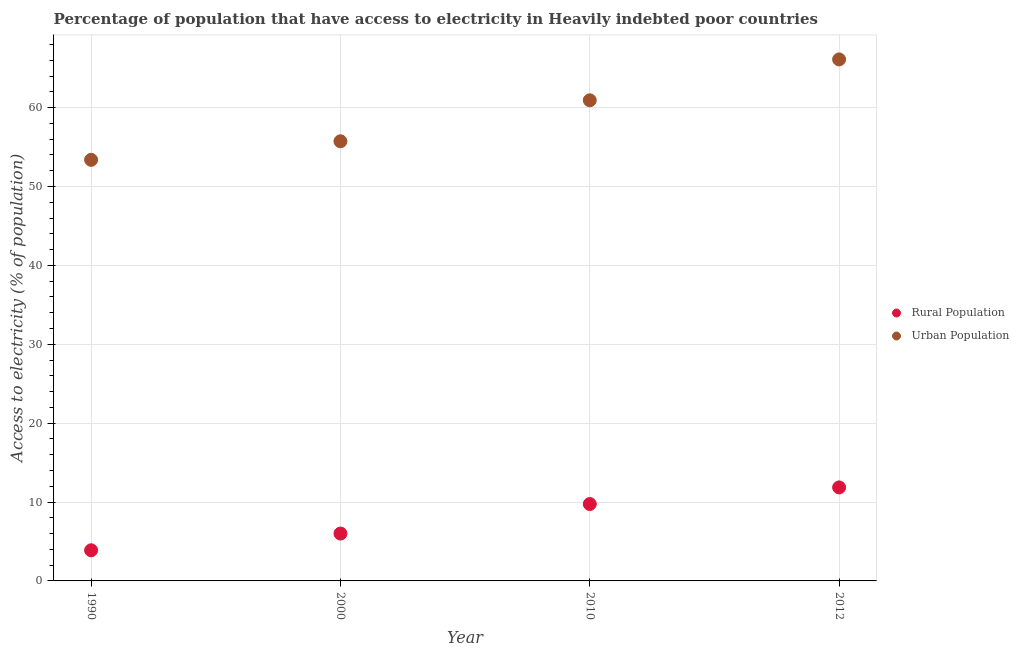Is the number of dotlines equal to the number of legend labels?
Offer a terse response. Yes. What is the percentage of urban population having access to electricity in 2000?
Provide a succinct answer. 55.73. Across all years, what is the maximum percentage of rural population having access to electricity?
Your response must be concise. 11.85. Across all years, what is the minimum percentage of rural population having access to electricity?
Provide a succinct answer. 3.88. In which year was the percentage of urban population having access to electricity minimum?
Give a very brief answer. 1990. What is the total percentage of rural population having access to electricity in the graph?
Make the answer very short. 31.49. What is the difference between the percentage of urban population having access to electricity in 1990 and that in 2000?
Offer a terse response. -2.35. What is the difference between the percentage of urban population having access to electricity in 2010 and the percentage of rural population having access to electricity in 1990?
Provide a succinct answer. 57.04. What is the average percentage of rural population having access to electricity per year?
Provide a short and direct response. 7.87. In the year 1990, what is the difference between the percentage of rural population having access to electricity and percentage of urban population having access to electricity?
Keep it short and to the point. -49.49. In how many years, is the percentage of urban population having access to electricity greater than 44 %?
Your response must be concise. 4. What is the ratio of the percentage of urban population having access to electricity in 2010 to that in 2012?
Your answer should be very brief. 0.92. Is the percentage of rural population having access to electricity in 1990 less than that in 2012?
Keep it short and to the point. Yes. Is the difference between the percentage of rural population having access to electricity in 2000 and 2012 greater than the difference between the percentage of urban population having access to electricity in 2000 and 2012?
Provide a short and direct response. Yes. What is the difference between the highest and the second highest percentage of urban population having access to electricity?
Your answer should be compact. 5.18. What is the difference between the highest and the lowest percentage of urban population having access to electricity?
Offer a very short reply. 12.73. Is the sum of the percentage of rural population having access to electricity in 1990 and 2000 greater than the maximum percentage of urban population having access to electricity across all years?
Your answer should be compact. No. Does the percentage of rural population having access to electricity monotonically increase over the years?
Provide a succinct answer. Yes. How many years are there in the graph?
Your response must be concise. 4. Does the graph contain any zero values?
Give a very brief answer. No. Does the graph contain grids?
Your response must be concise. Yes. How many legend labels are there?
Your response must be concise. 2. How are the legend labels stacked?
Provide a short and direct response. Vertical. What is the title of the graph?
Your response must be concise. Percentage of population that have access to electricity in Heavily indebted poor countries. What is the label or title of the X-axis?
Offer a very short reply. Year. What is the label or title of the Y-axis?
Provide a short and direct response. Access to electricity (% of population). What is the Access to electricity (% of population) of Rural Population in 1990?
Make the answer very short. 3.88. What is the Access to electricity (% of population) of Urban Population in 1990?
Your answer should be compact. 53.37. What is the Access to electricity (% of population) in Rural Population in 2000?
Provide a succinct answer. 6. What is the Access to electricity (% of population) of Urban Population in 2000?
Your response must be concise. 55.73. What is the Access to electricity (% of population) in Rural Population in 2010?
Provide a short and direct response. 9.75. What is the Access to electricity (% of population) of Urban Population in 2010?
Give a very brief answer. 60.92. What is the Access to electricity (% of population) in Rural Population in 2012?
Offer a very short reply. 11.85. What is the Access to electricity (% of population) of Urban Population in 2012?
Make the answer very short. 66.1. Across all years, what is the maximum Access to electricity (% of population) of Rural Population?
Your answer should be compact. 11.85. Across all years, what is the maximum Access to electricity (% of population) in Urban Population?
Your answer should be very brief. 66.1. Across all years, what is the minimum Access to electricity (% of population) in Rural Population?
Keep it short and to the point. 3.88. Across all years, what is the minimum Access to electricity (% of population) of Urban Population?
Give a very brief answer. 53.37. What is the total Access to electricity (% of population) of Rural Population in the graph?
Your response must be concise. 31.49. What is the total Access to electricity (% of population) in Urban Population in the graph?
Make the answer very short. 236.12. What is the difference between the Access to electricity (% of population) in Rural Population in 1990 and that in 2000?
Offer a terse response. -2.12. What is the difference between the Access to electricity (% of population) of Urban Population in 1990 and that in 2000?
Your response must be concise. -2.35. What is the difference between the Access to electricity (% of population) of Rural Population in 1990 and that in 2010?
Your response must be concise. -5.86. What is the difference between the Access to electricity (% of population) in Urban Population in 1990 and that in 2010?
Offer a terse response. -7.55. What is the difference between the Access to electricity (% of population) in Rural Population in 1990 and that in 2012?
Offer a terse response. -7.97. What is the difference between the Access to electricity (% of population) of Urban Population in 1990 and that in 2012?
Provide a short and direct response. -12.73. What is the difference between the Access to electricity (% of population) in Rural Population in 2000 and that in 2010?
Offer a very short reply. -3.74. What is the difference between the Access to electricity (% of population) of Urban Population in 2000 and that in 2010?
Make the answer very short. -5.19. What is the difference between the Access to electricity (% of population) in Rural Population in 2000 and that in 2012?
Your response must be concise. -5.85. What is the difference between the Access to electricity (% of population) in Urban Population in 2000 and that in 2012?
Your response must be concise. -10.37. What is the difference between the Access to electricity (% of population) of Rural Population in 2010 and that in 2012?
Offer a very short reply. -2.11. What is the difference between the Access to electricity (% of population) of Urban Population in 2010 and that in 2012?
Make the answer very short. -5.18. What is the difference between the Access to electricity (% of population) in Rural Population in 1990 and the Access to electricity (% of population) in Urban Population in 2000?
Keep it short and to the point. -51.84. What is the difference between the Access to electricity (% of population) of Rural Population in 1990 and the Access to electricity (% of population) of Urban Population in 2010?
Give a very brief answer. -57.04. What is the difference between the Access to electricity (% of population) of Rural Population in 1990 and the Access to electricity (% of population) of Urban Population in 2012?
Your answer should be very brief. -62.22. What is the difference between the Access to electricity (% of population) in Rural Population in 2000 and the Access to electricity (% of population) in Urban Population in 2010?
Your response must be concise. -54.92. What is the difference between the Access to electricity (% of population) of Rural Population in 2000 and the Access to electricity (% of population) of Urban Population in 2012?
Offer a terse response. -60.1. What is the difference between the Access to electricity (% of population) of Rural Population in 2010 and the Access to electricity (% of population) of Urban Population in 2012?
Provide a short and direct response. -56.36. What is the average Access to electricity (% of population) in Rural Population per year?
Your answer should be compact. 7.87. What is the average Access to electricity (% of population) of Urban Population per year?
Provide a short and direct response. 59.03. In the year 1990, what is the difference between the Access to electricity (% of population) of Rural Population and Access to electricity (% of population) of Urban Population?
Your response must be concise. -49.49. In the year 2000, what is the difference between the Access to electricity (% of population) of Rural Population and Access to electricity (% of population) of Urban Population?
Offer a very short reply. -49.72. In the year 2010, what is the difference between the Access to electricity (% of population) of Rural Population and Access to electricity (% of population) of Urban Population?
Your answer should be very brief. -51.18. In the year 2012, what is the difference between the Access to electricity (% of population) of Rural Population and Access to electricity (% of population) of Urban Population?
Make the answer very short. -54.25. What is the ratio of the Access to electricity (% of population) in Rural Population in 1990 to that in 2000?
Keep it short and to the point. 0.65. What is the ratio of the Access to electricity (% of population) of Urban Population in 1990 to that in 2000?
Your answer should be very brief. 0.96. What is the ratio of the Access to electricity (% of population) of Rural Population in 1990 to that in 2010?
Provide a short and direct response. 0.4. What is the ratio of the Access to electricity (% of population) in Urban Population in 1990 to that in 2010?
Offer a very short reply. 0.88. What is the ratio of the Access to electricity (% of population) in Rural Population in 1990 to that in 2012?
Give a very brief answer. 0.33. What is the ratio of the Access to electricity (% of population) of Urban Population in 1990 to that in 2012?
Keep it short and to the point. 0.81. What is the ratio of the Access to electricity (% of population) of Rural Population in 2000 to that in 2010?
Offer a very short reply. 0.62. What is the ratio of the Access to electricity (% of population) of Urban Population in 2000 to that in 2010?
Offer a terse response. 0.91. What is the ratio of the Access to electricity (% of population) in Rural Population in 2000 to that in 2012?
Offer a terse response. 0.51. What is the ratio of the Access to electricity (% of population) of Urban Population in 2000 to that in 2012?
Provide a short and direct response. 0.84. What is the ratio of the Access to electricity (% of population) of Rural Population in 2010 to that in 2012?
Keep it short and to the point. 0.82. What is the ratio of the Access to electricity (% of population) of Urban Population in 2010 to that in 2012?
Ensure brevity in your answer.  0.92. What is the difference between the highest and the second highest Access to electricity (% of population) of Rural Population?
Make the answer very short. 2.11. What is the difference between the highest and the second highest Access to electricity (% of population) of Urban Population?
Make the answer very short. 5.18. What is the difference between the highest and the lowest Access to electricity (% of population) of Rural Population?
Provide a short and direct response. 7.97. What is the difference between the highest and the lowest Access to electricity (% of population) in Urban Population?
Offer a very short reply. 12.73. 